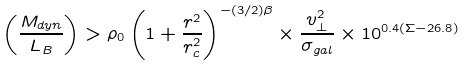Convert formula to latex. <formula><loc_0><loc_0><loc_500><loc_500>\left ( \frac { M _ { d y n } } { L _ { B } } \right ) > \rho _ { 0 } \left ( 1 + \frac { r ^ { 2 } } { r _ { c } ^ { 2 } } \right ) ^ { - ( 3 / 2 ) \beta } \times \frac { v _ { \bot } ^ { 2 } } { \sigma _ { g a l } } \times 1 0 ^ { 0 . 4 ( \Sigma - 2 6 . 8 ) }</formula> 